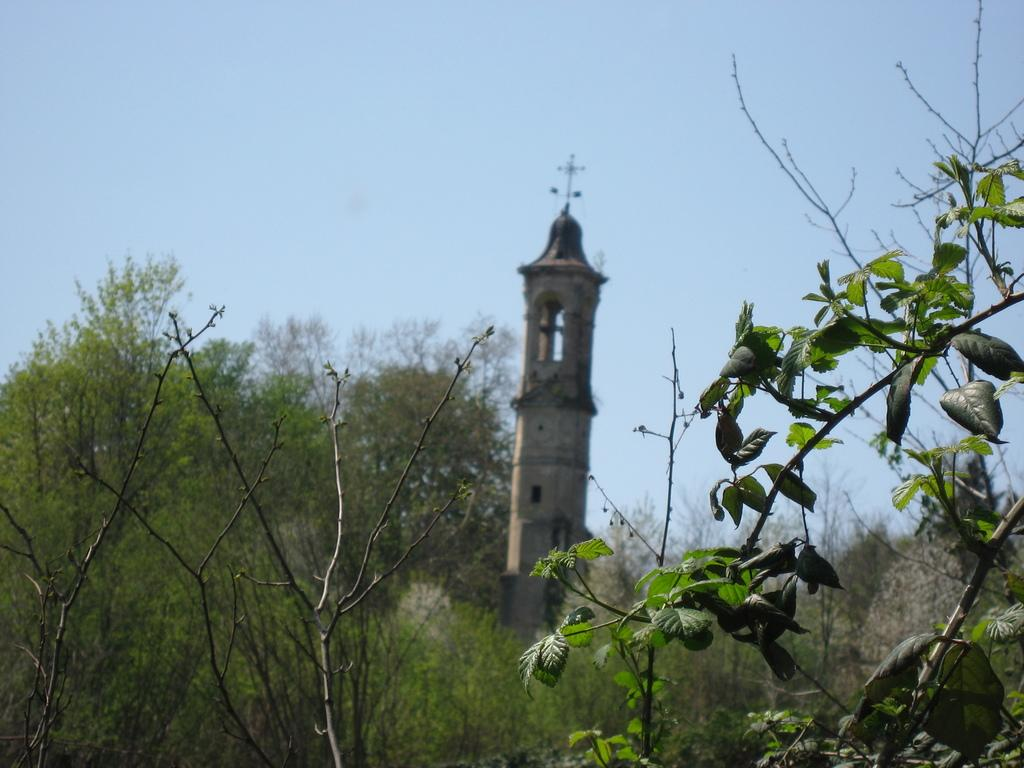What type of vegetation or plants can be seen at the bottom of the image? There is greenery at the bottom side of the image. What is the main structure or object in the center of the image? There is a tower in the center of the image. How many giants can be seen holding an icicle in the image? There are no giants or icicles present in the image. 